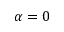Convert formula to latex. <formula><loc_0><loc_0><loc_500><loc_500>\alpha = 0</formula> 